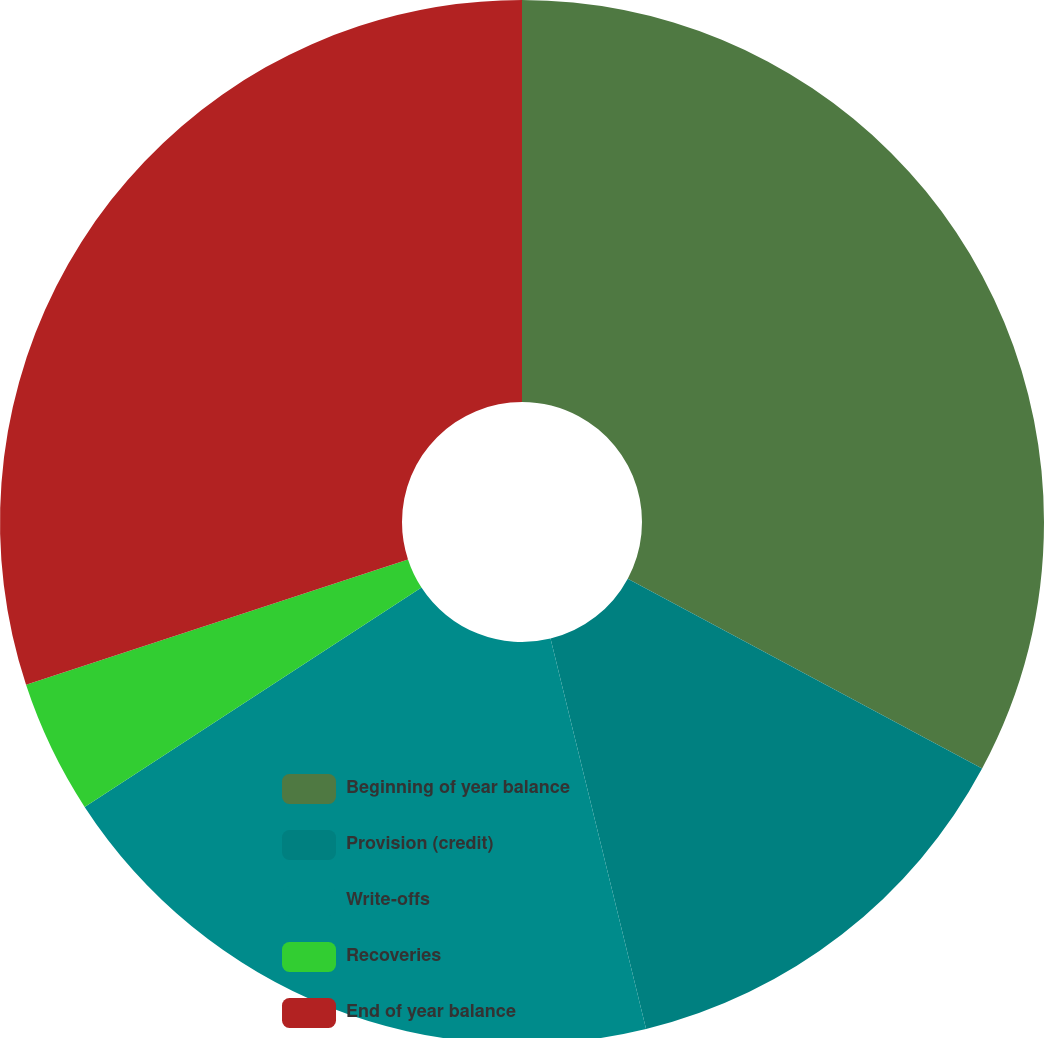Convert chart. <chart><loc_0><loc_0><loc_500><loc_500><pie_chart><fcel>Beginning of year balance<fcel>Provision (credit)<fcel>Write-offs<fcel>Recoveries<fcel>End of year balance<nl><fcel>32.83%<fcel>13.35%<fcel>19.63%<fcel>4.14%<fcel>30.05%<nl></chart> 